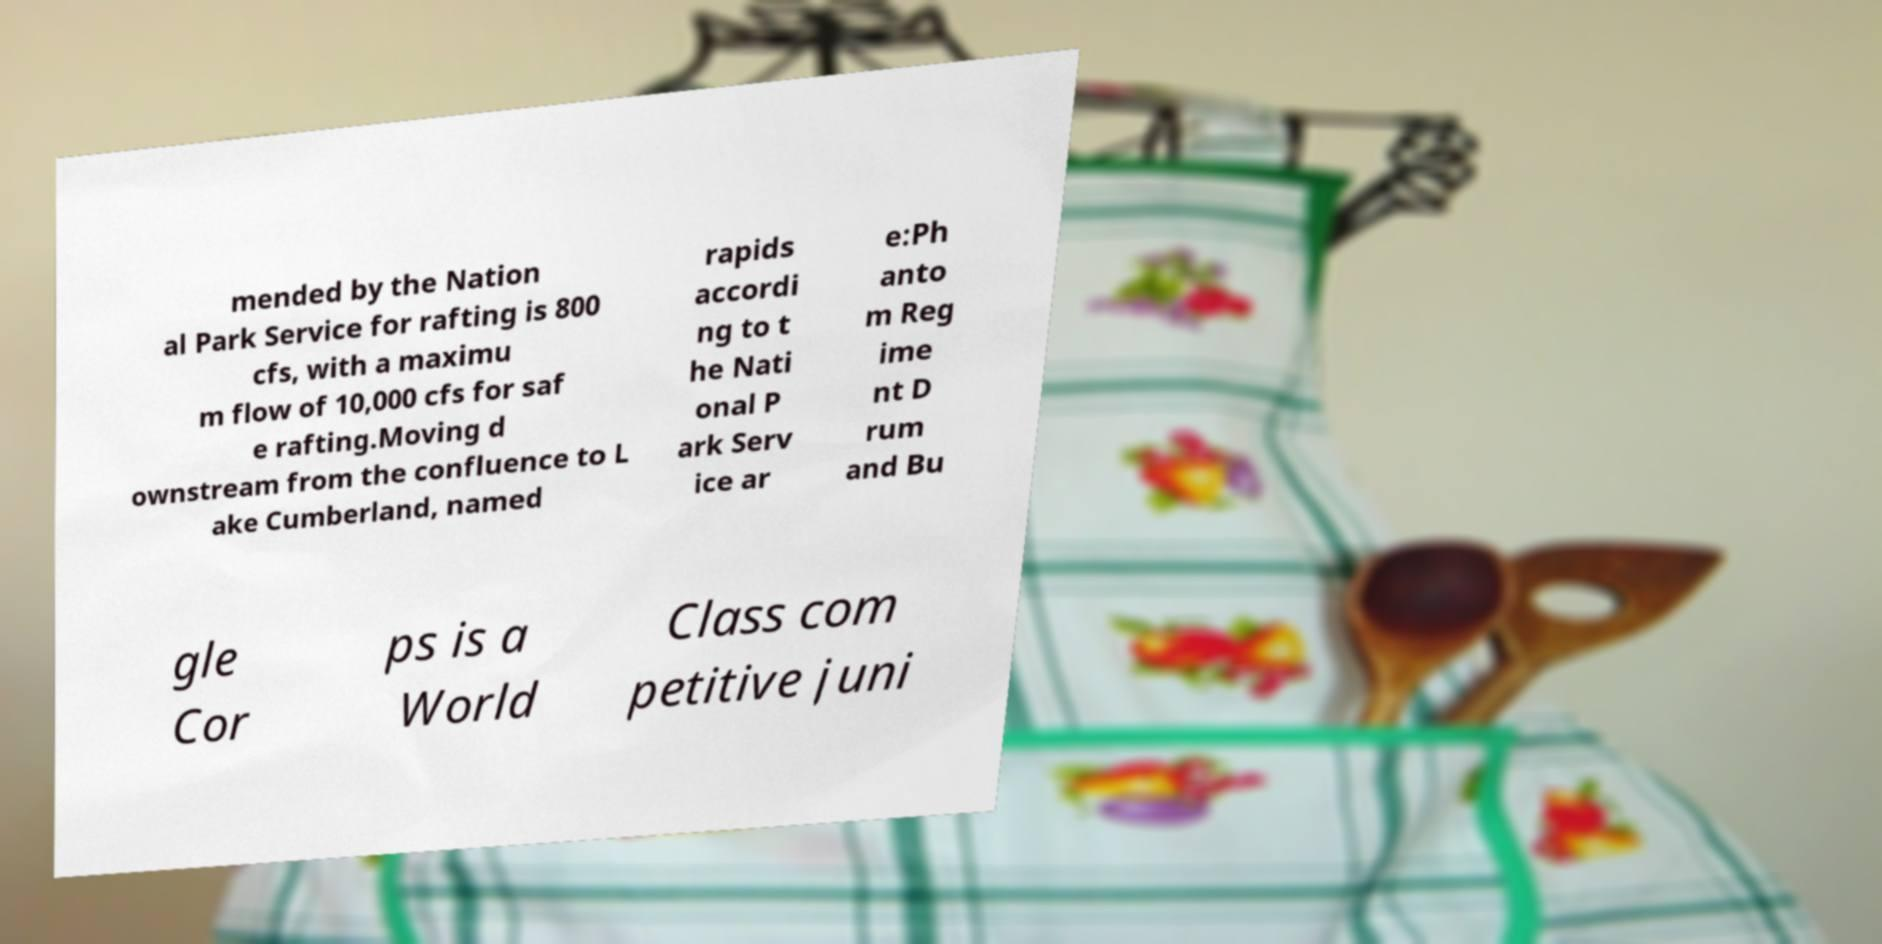I need the written content from this picture converted into text. Can you do that? mended by the Nation al Park Service for rafting is 800 cfs, with a maximu m flow of 10,000 cfs for saf e rafting.Moving d ownstream from the confluence to L ake Cumberland, named rapids accordi ng to t he Nati onal P ark Serv ice ar e:Ph anto m Reg ime nt D rum and Bu gle Cor ps is a World Class com petitive juni 